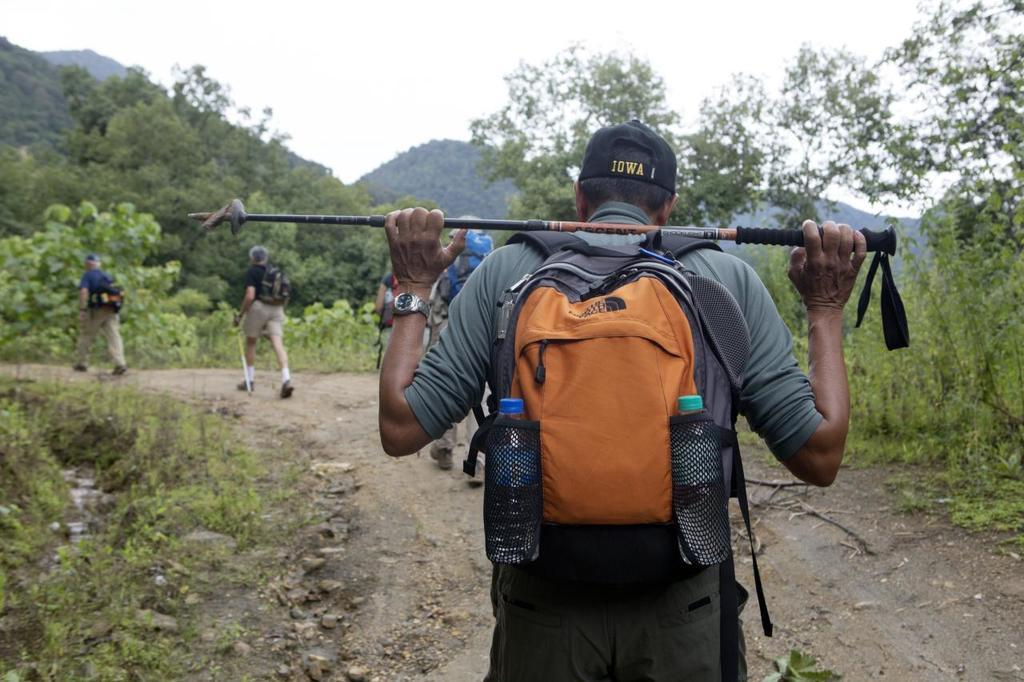What is the man in the image carrying on his back? The man in the image is wearing a backpack. What can be seen in the background of the image? There is a sky, a tree, a hill, plants, grass, and other persons walking on the road visible in the background of the image. What type of cracker is the man eating in the image? There is no cracker present in the image; the man is wearing a backpack. Whose birthday is being celebrated in the image? There is no indication of a birthday celebration in the image. 